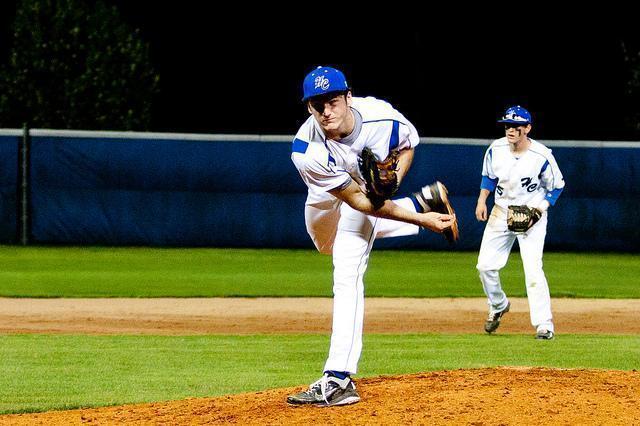Why does the man stand on one leg?
Indicate the correct response and explain using: 'Answer: answer
Rationale: rationale.'
Options: Running bases, pitching ball, stork pose, yoga move. Answer: pitching ball.
Rationale: The power of his throw moves his weight forward throwing up his back leg. 